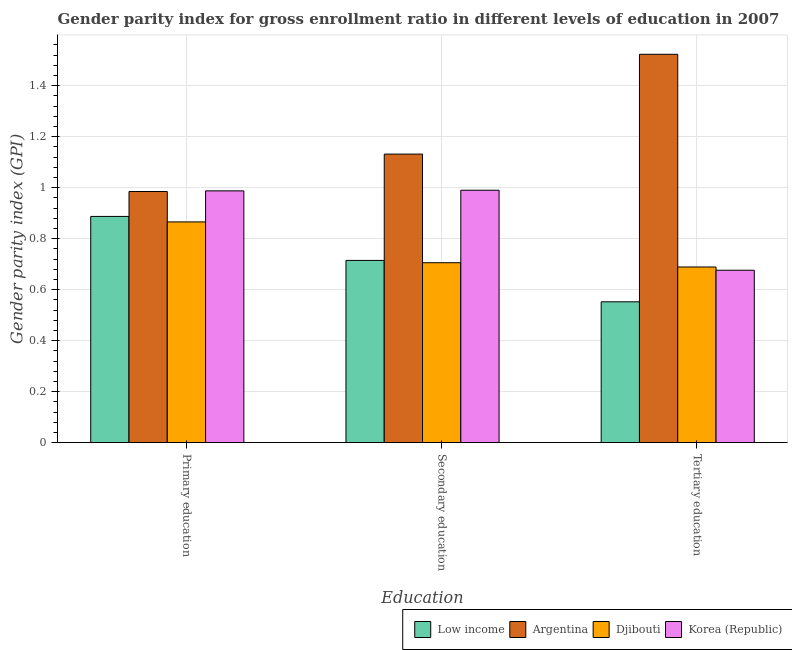How many different coloured bars are there?
Your response must be concise. 4. How many groups of bars are there?
Your answer should be compact. 3. Are the number of bars per tick equal to the number of legend labels?
Provide a succinct answer. Yes. Are the number of bars on each tick of the X-axis equal?
Your answer should be compact. Yes. How many bars are there on the 3rd tick from the right?
Make the answer very short. 4. What is the label of the 2nd group of bars from the left?
Your response must be concise. Secondary education. What is the gender parity index in primary education in Argentina?
Your answer should be compact. 0.99. Across all countries, what is the maximum gender parity index in tertiary education?
Your response must be concise. 1.52. Across all countries, what is the minimum gender parity index in primary education?
Offer a terse response. 0.87. In which country was the gender parity index in primary education minimum?
Ensure brevity in your answer.  Djibouti. What is the total gender parity index in tertiary education in the graph?
Give a very brief answer. 3.44. What is the difference between the gender parity index in tertiary education in Argentina and that in Low income?
Offer a very short reply. 0.97. What is the difference between the gender parity index in primary education in Djibouti and the gender parity index in tertiary education in Low income?
Ensure brevity in your answer.  0.31. What is the average gender parity index in tertiary education per country?
Your answer should be compact. 0.86. What is the difference between the gender parity index in tertiary education and gender parity index in primary education in Low income?
Offer a very short reply. -0.33. What is the ratio of the gender parity index in tertiary education in Djibouti to that in Argentina?
Provide a succinct answer. 0.45. Is the gender parity index in secondary education in Low income less than that in Djibouti?
Make the answer very short. No. What is the difference between the highest and the second highest gender parity index in tertiary education?
Offer a very short reply. 0.83. What is the difference between the highest and the lowest gender parity index in primary education?
Your answer should be very brief. 0.12. In how many countries, is the gender parity index in secondary education greater than the average gender parity index in secondary education taken over all countries?
Your answer should be very brief. 2. Is the sum of the gender parity index in tertiary education in Argentina and Djibouti greater than the maximum gender parity index in primary education across all countries?
Provide a succinct answer. Yes. What does the 2nd bar from the left in Primary education represents?
Your answer should be very brief. Argentina. What does the 3rd bar from the right in Secondary education represents?
Ensure brevity in your answer.  Argentina. Are all the bars in the graph horizontal?
Your answer should be compact. No. What is the difference between two consecutive major ticks on the Y-axis?
Keep it short and to the point. 0.2. Does the graph contain any zero values?
Your answer should be very brief. No. Does the graph contain grids?
Offer a very short reply. Yes. How are the legend labels stacked?
Provide a short and direct response. Horizontal. What is the title of the graph?
Provide a succinct answer. Gender parity index for gross enrollment ratio in different levels of education in 2007. What is the label or title of the X-axis?
Offer a terse response. Education. What is the label or title of the Y-axis?
Your response must be concise. Gender parity index (GPI). What is the Gender parity index (GPI) of Low income in Primary education?
Your response must be concise. 0.89. What is the Gender parity index (GPI) in Argentina in Primary education?
Give a very brief answer. 0.99. What is the Gender parity index (GPI) of Djibouti in Primary education?
Provide a succinct answer. 0.87. What is the Gender parity index (GPI) of Korea (Republic) in Primary education?
Provide a succinct answer. 0.99. What is the Gender parity index (GPI) in Low income in Secondary education?
Offer a very short reply. 0.71. What is the Gender parity index (GPI) of Argentina in Secondary education?
Offer a terse response. 1.13. What is the Gender parity index (GPI) in Djibouti in Secondary education?
Ensure brevity in your answer.  0.71. What is the Gender parity index (GPI) of Korea (Republic) in Secondary education?
Make the answer very short. 0.99. What is the Gender parity index (GPI) of Low income in Tertiary education?
Your response must be concise. 0.55. What is the Gender parity index (GPI) of Argentina in Tertiary education?
Make the answer very short. 1.52. What is the Gender parity index (GPI) in Djibouti in Tertiary education?
Provide a short and direct response. 0.69. What is the Gender parity index (GPI) of Korea (Republic) in Tertiary education?
Your answer should be compact. 0.68. Across all Education, what is the maximum Gender parity index (GPI) of Low income?
Offer a very short reply. 0.89. Across all Education, what is the maximum Gender parity index (GPI) of Argentina?
Give a very brief answer. 1.52. Across all Education, what is the maximum Gender parity index (GPI) in Djibouti?
Offer a very short reply. 0.87. Across all Education, what is the maximum Gender parity index (GPI) in Korea (Republic)?
Keep it short and to the point. 0.99. Across all Education, what is the minimum Gender parity index (GPI) in Low income?
Give a very brief answer. 0.55. Across all Education, what is the minimum Gender parity index (GPI) in Argentina?
Provide a short and direct response. 0.99. Across all Education, what is the minimum Gender parity index (GPI) of Djibouti?
Provide a succinct answer. 0.69. Across all Education, what is the minimum Gender parity index (GPI) in Korea (Republic)?
Provide a short and direct response. 0.68. What is the total Gender parity index (GPI) of Low income in the graph?
Provide a succinct answer. 2.15. What is the total Gender parity index (GPI) of Argentina in the graph?
Make the answer very short. 3.64. What is the total Gender parity index (GPI) in Djibouti in the graph?
Offer a very short reply. 2.26. What is the total Gender parity index (GPI) in Korea (Republic) in the graph?
Your answer should be very brief. 2.65. What is the difference between the Gender parity index (GPI) of Low income in Primary education and that in Secondary education?
Keep it short and to the point. 0.17. What is the difference between the Gender parity index (GPI) of Argentina in Primary education and that in Secondary education?
Your answer should be very brief. -0.15. What is the difference between the Gender parity index (GPI) of Djibouti in Primary education and that in Secondary education?
Offer a terse response. 0.16. What is the difference between the Gender parity index (GPI) in Korea (Republic) in Primary education and that in Secondary education?
Provide a short and direct response. -0. What is the difference between the Gender parity index (GPI) in Low income in Primary education and that in Tertiary education?
Make the answer very short. 0.33. What is the difference between the Gender parity index (GPI) of Argentina in Primary education and that in Tertiary education?
Offer a terse response. -0.54. What is the difference between the Gender parity index (GPI) in Djibouti in Primary education and that in Tertiary education?
Your response must be concise. 0.18. What is the difference between the Gender parity index (GPI) of Korea (Republic) in Primary education and that in Tertiary education?
Give a very brief answer. 0.31. What is the difference between the Gender parity index (GPI) of Low income in Secondary education and that in Tertiary education?
Provide a short and direct response. 0.16. What is the difference between the Gender parity index (GPI) in Argentina in Secondary education and that in Tertiary education?
Provide a short and direct response. -0.39. What is the difference between the Gender parity index (GPI) in Djibouti in Secondary education and that in Tertiary education?
Make the answer very short. 0.02. What is the difference between the Gender parity index (GPI) of Korea (Republic) in Secondary education and that in Tertiary education?
Your answer should be compact. 0.31. What is the difference between the Gender parity index (GPI) of Low income in Primary education and the Gender parity index (GPI) of Argentina in Secondary education?
Your answer should be very brief. -0.24. What is the difference between the Gender parity index (GPI) in Low income in Primary education and the Gender parity index (GPI) in Djibouti in Secondary education?
Give a very brief answer. 0.18. What is the difference between the Gender parity index (GPI) in Low income in Primary education and the Gender parity index (GPI) in Korea (Republic) in Secondary education?
Make the answer very short. -0.1. What is the difference between the Gender parity index (GPI) in Argentina in Primary education and the Gender parity index (GPI) in Djibouti in Secondary education?
Provide a short and direct response. 0.28. What is the difference between the Gender parity index (GPI) of Argentina in Primary education and the Gender parity index (GPI) of Korea (Republic) in Secondary education?
Provide a short and direct response. -0.01. What is the difference between the Gender parity index (GPI) in Djibouti in Primary education and the Gender parity index (GPI) in Korea (Republic) in Secondary education?
Your answer should be compact. -0.12. What is the difference between the Gender parity index (GPI) of Low income in Primary education and the Gender parity index (GPI) of Argentina in Tertiary education?
Give a very brief answer. -0.64. What is the difference between the Gender parity index (GPI) of Low income in Primary education and the Gender parity index (GPI) of Djibouti in Tertiary education?
Provide a succinct answer. 0.2. What is the difference between the Gender parity index (GPI) of Low income in Primary education and the Gender parity index (GPI) of Korea (Republic) in Tertiary education?
Your response must be concise. 0.21. What is the difference between the Gender parity index (GPI) in Argentina in Primary education and the Gender parity index (GPI) in Djibouti in Tertiary education?
Give a very brief answer. 0.3. What is the difference between the Gender parity index (GPI) of Argentina in Primary education and the Gender parity index (GPI) of Korea (Republic) in Tertiary education?
Your answer should be very brief. 0.31. What is the difference between the Gender parity index (GPI) in Djibouti in Primary education and the Gender parity index (GPI) in Korea (Republic) in Tertiary education?
Provide a short and direct response. 0.19. What is the difference between the Gender parity index (GPI) of Low income in Secondary education and the Gender parity index (GPI) of Argentina in Tertiary education?
Ensure brevity in your answer.  -0.81. What is the difference between the Gender parity index (GPI) of Low income in Secondary education and the Gender parity index (GPI) of Djibouti in Tertiary education?
Ensure brevity in your answer.  0.03. What is the difference between the Gender parity index (GPI) in Low income in Secondary education and the Gender parity index (GPI) in Korea (Republic) in Tertiary education?
Your answer should be compact. 0.04. What is the difference between the Gender parity index (GPI) of Argentina in Secondary education and the Gender parity index (GPI) of Djibouti in Tertiary education?
Keep it short and to the point. 0.44. What is the difference between the Gender parity index (GPI) in Argentina in Secondary education and the Gender parity index (GPI) in Korea (Republic) in Tertiary education?
Your answer should be compact. 0.46. What is the difference between the Gender parity index (GPI) in Djibouti in Secondary education and the Gender parity index (GPI) in Korea (Republic) in Tertiary education?
Provide a succinct answer. 0.03. What is the average Gender parity index (GPI) of Low income per Education?
Make the answer very short. 0.72. What is the average Gender parity index (GPI) of Argentina per Education?
Give a very brief answer. 1.21. What is the average Gender parity index (GPI) of Djibouti per Education?
Provide a short and direct response. 0.75. What is the average Gender parity index (GPI) in Korea (Republic) per Education?
Your response must be concise. 0.88. What is the difference between the Gender parity index (GPI) of Low income and Gender parity index (GPI) of Argentina in Primary education?
Make the answer very short. -0.1. What is the difference between the Gender parity index (GPI) of Low income and Gender parity index (GPI) of Djibouti in Primary education?
Your answer should be compact. 0.02. What is the difference between the Gender parity index (GPI) of Low income and Gender parity index (GPI) of Korea (Republic) in Primary education?
Your answer should be very brief. -0.1. What is the difference between the Gender parity index (GPI) of Argentina and Gender parity index (GPI) of Djibouti in Primary education?
Your answer should be very brief. 0.12. What is the difference between the Gender parity index (GPI) of Argentina and Gender parity index (GPI) of Korea (Republic) in Primary education?
Your response must be concise. -0. What is the difference between the Gender parity index (GPI) in Djibouti and Gender parity index (GPI) in Korea (Republic) in Primary education?
Your answer should be compact. -0.12. What is the difference between the Gender parity index (GPI) in Low income and Gender parity index (GPI) in Argentina in Secondary education?
Ensure brevity in your answer.  -0.42. What is the difference between the Gender parity index (GPI) in Low income and Gender parity index (GPI) in Djibouti in Secondary education?
Your answer should be compact. 0.01. What is the difference between the Gender parity index (GPI) of Low income and Gender parity index (GPI) of Korea (Republic) in Secondary education?
Make the answer very short. -0.28. What is the difference between the Gender parity index (GPI) in Argentina and Gender parity index (GPI) in Djibouti in Secondary education?
Ensure brevity in your answer.  0.43. What is the difference between the Gender parity index (GPI) in Argentina and Gender parity index (GPI) in Korea (Republic) in Secondary education?
Provide a short and direct response. 0.14. What is the difference between the Gender parity index (GPI) in Djibouti and Gender parity index (GPI) in Korea (Republic) in Secondary education?
Offer a terse response. -0.28. What is the difference between the Gender parity index (GPI) in Low income and Gender parity index (GPI) in Argentina in Tertiary education?
Your answer should be very brief. -0.97. What is the difference between the Gender parity index (GPI) in Low income and Gender parity index (GPI) in Djibouti in Tertiary education?
Your answer should be very brief. -0.14. What is the difference between the Gender parity index (GPI) in Low income and Gender parity index (GPI) in Korea (Republic) in Tertiary education?
Make the answer very short. -0.12. What is the difference between the Gender parity index (GPI) in Argentina and Gender parity index (GPI) in Djibouti in Tertiary education?
Give a very brief answer. 0.83. What is the difference between the Gender parity index (GPI) of Argentina and Gender parity index (GPI) of Korea (Republic) in Tertiary education?
Provide a succinct answer. 0.85. What is the difference between the Gender parity index (GPI) in Djibouti and Gender parity index (GPI) in Korea (Republic) in Tertiary education?
Give a very brief answer. 0.01. What is the ratio of the Gender parity index (GPI) of Low income in Primary education to that in Secondary education?
Ensure brevity in your answer.  1.24. What is the ratio of the Gender parity index (GPI) of Argentina in Primary education to that in Secondary education?
Make the answer very short. 0.87. What is the ratio of the Gender parity index (GPI) of Djibouti in Primary education to that in Secondary education?
Your answer should be compact. 1.23. What is the ratio of the Gender parity index (GPI) of Low income in Primary education to that in Tertiary education?
Give a very brief answer. 1.61. What is the ratio of the Gender parity index (GPI) in Argentina in Primary education to that in Tertiary education?
Provide a short and direct response. 0.65. What is the ratio of the Gender parity index (GPI) in Djibouti in Primary education to that in Tertiary education?
Provide a succinct answer. 1.26. What is the ratio of the Gender parity index (GPI) in Korea (Republic) in Primary education to that in Tertiary education?
Give a very brief answer. 1.46. What is the ratio of the Gender parity index (GPI) in Low income in Secondary education to that in Tertiary education?
Make the answer very short. 1.29. What is the ratio of the Gender parity index (GPI) of Argentina in Secondary education to that in Tertiary education?
Give a very brief answer. 0.74. What is the ratio of the Gender parity index (GPI) in Djibouti in Secondary education to that in Tertiary education?
Ensure brevity in your answer.  1.02. What is the ratio of the Gender parity index (GPI) of Korea (Republic) in Secondary education to that in Tertiary education?
Your response must be concise. 1.46. What is the difference between the highest and the second highest Gender parity index (GPI) of Low income?
Offer a terse response. 0.17. What is the difference between the highest and the second highest Gender parity index (GPI) in Argentina?
Ensure brevity in your answer.  0.39. What is the difference between the highest and the second highest Gender parity index (GPI) of Djibouti?
Offer a very short reply. 0.16. What is the difference between the highest and the second highest Gender parity index (GPI) of Korea (Republic)?
Give a very brief answer. 0. What is the difference between the highest and the lowest Gender parity index (GPI) of Low income?
Your response must be concise. 0.33. What is the difference between the highest and the lowest Gender parity index (GPI) in Argentina?
Make the answer very short. 0.54. What is the difference between the highest and the lowest Gender parity index (GPI) in Djibouti?
Provide a succinct answer. 0.18. What is the difference between the highest and the lowest Gender parity index (GPI) of Korea (Republic)?
Your response must be concise. 0.31. 